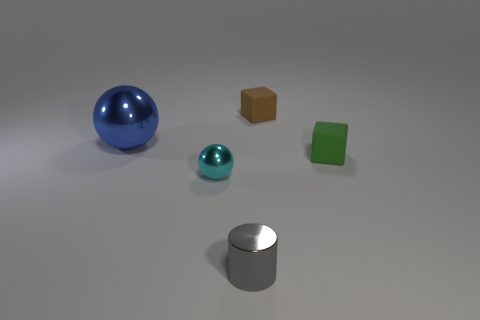What number of small things are either gray shiny cylinders or brown rubber things?
Give a very brief answer. 2. How many spheres are the same material as the green thing?
Your answer should be compact. 0. There is a metallic sphere that is in front of the large metallic thing; what is its size?
Your answer should be very brief. Small. There is a thing that is in front of the small shiny thing on the left side of the gray metallic cylinder; what is its shape?
Make the answer very short. Cylinder. There is a tiny block that is behind the matte object that is in front of the brown block; how many small matte objects are on the right side of it?
Offer a terse response. 1. Are there fewer tiny spheres behind the small sphere than blue cylinders?
Your answer should be compact. No. Is there anything else that is the same shape as the gray object?
Keep it short and to the point. No. What shape is the metal thing behind the small green thing?
Give a very brief answer. Sphere. What is the shape of the metal thing that is behind the small shiny thing behind the tiny gray shiny cylinder in front of the tiny brown thing?
Your response must be concise. Sphere. How many things are tiny green shiny cubes or small green cubes?
Ensure brevity in your answer.  1. 